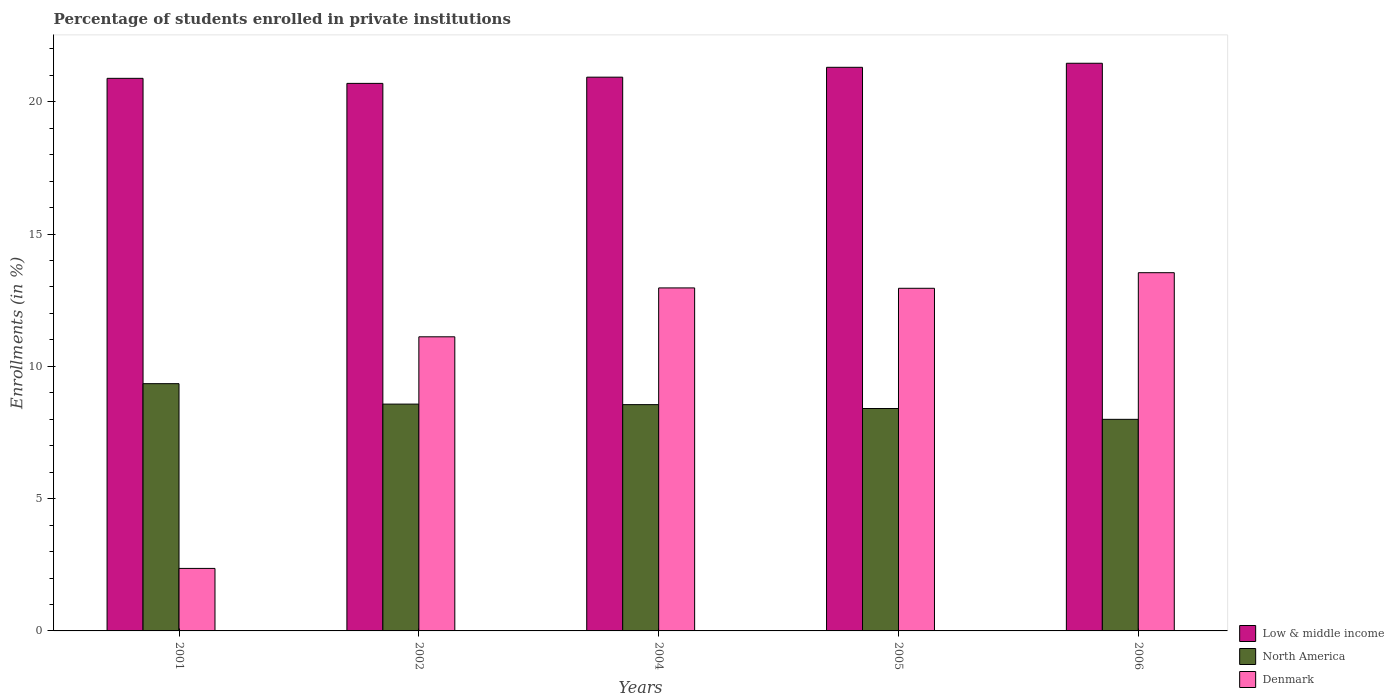How many different coloured bars are there?
Offer a terse response. 3. Are the number of bars per tick equal to the number of legend labels?
Provide a short and direct response. Yes. Are the number of bars on each tick of the X-axis equal?
Your response must be concise. Yes. How many bars are there on the 4th tick from the right?
Keep it short and to the point. 3. What is the percentage of trained teachers in Denmark in 2001?
Ensure brevity in your answer.  2.36. Across all years, what is the maximum percentage of trained teachers in North America?
Provide a short and direct response. 9.35. Across all years, what is the minimum percentage of trained teachers in Denmark?
Provide a succinct answer. 2.36. In which year was the percentage of trained teachers in Low & middle income minimum?
Make the answer very short. 2002. What is the total percentage of trained teachers in Low & middle income in the graph?
Your answer should be compact. 105.27. What is the difference between the percentage of trained teachers in Low & middle income in 2001 and that in 2006?
Give a very brief answer. -0.57. What is the difference between the percentage of trained teachers in North America in 2002 and the percentage of trained teachers in Denmark in 2004?
Provide a short and direct response. -4.39. What is the average percentage of trained teachers in Low & middle income per year?
Your answer should be compact. 21.05. In the year 2001, what is the difference between the percentage of trained teachers in Low & middle income and percentage of trained teachers in Denmark?
Offer a very short reply. 18.52. In how many years, is the percentage of trained teachers in Denmark greater than 4 %?
Ensure brevity in your answer.  4. What is the ratio of the percentage of trained teachers in North America in 2005 to that in 2006?
Ensure brevity in your answer.  1.05. What is the difference between the highest and the second highest percentage of trained teachers in North America?
Give a very brief answer. 0.77. What is the difference between the highest and the lowest percentage of trained teachers in Denmark?
Ensure brevity in your answer.  11.18. In how many years, is the percentage of trained teachers in Denmark greater than the average percentage of trained teachers in Denmark taken over all years?
Ensure brevity in your answer.  4. What does the 1st bar from the left in 2006 represents?
Make the answer very short. Low & middle income. What does the 2nd bar from the right in 2006 represents?
Offer a terse response. North America. How many bars are there?
Offer a very short reply. 15. What is the difference between two consecutive major ticks on the Y-axis?
Provide a short and direct response. 5. How are the legend labels stacked?
Provide a succinct answer. Vertical. What is the title of the graph?
Keep it short and to the point. Percentage of students enrolled in private institutions. Does "Kosovo" appear as one of the legend labels in the graph?
Offer a terse response. No. What is the label or title of the Y-axis?
Your response must be concise. Enrollments (in %). What is the Enrollments (in %) in Low & middle income in 2001?
Your response must be concise. 20.89. What is the Enrollments (in %) of North America in 2001?
Your answer should be compact. 9.35. What is the Enrollments (in %) of Denmark in 2001?
Provide a succinct answer. 2.36. What is the Enrollments (in %) of Low & middle income in 2002?
Your response must be concise. 20.7. What is the Enrollments (in %) of North America in 2002?
Provide a short and direct response. 8.57. What is the Enrollments (in %) in Denmark in 2002?
Offer a very short reply. 11.12. What is the Enrollments (in %) in Low & middle income in 2004?
Offer a very short reply. 20.93. What is the Enrollments (in %) in North America in 2004?
Make the answer very short. 8.55. What is the Enrollments (in %) of Denmark in 2004?
Provide a succinct answer. 12.96. What is the Enrollments (in %) in Low & middle income in 2005?
Your answer should be very brief. 21.3. What is the Enrollments (in %) in North America in 2005?
Your answer should be compact. 8.41. What is the Enrollments (in %) in Denmark in 2005?
Keep it short and to the point. 12.95. What is the Enrollments (in %) in Low & middle income in 2006?
Offer a terse response. 21.46. What is the Enrollments (in %) in North America in 2006?
Give a very brief answer. 8. What is the Enrollments (in %) of Denmark in 2006?
Provide a short and direct response. 13.54. Across all years, what is the maximum Enrollments (in %) in Low & middle income?
Your answer should be very brief. 21.46. Across all years, what is the maximum Enrollments (in %) in North America?
Offer a very short reply. 9.35. Across all years, what is the maximum Enrollments (in %) of Denmark?
Your response must be concise. 13.54. Across all years, what is the minimum Enrollments (in %) in Low & middle income?
Provide a short and direct response. 20.7. Across all years, what is the minimum Enrollments (in %) in North America?
Your answer should be very brief. 8. Across all years, what is the minimum Enrollments (in %) in Denmark?
Ensure brevity in your answer.  2.36. What is the total Enrollments (in %) of Low & middle income in the graph?
Offer a very short reply. 105.27. What is the total Enrollments (in %) of North America in the graph?
Your answer should be very brief. 42.88. What is the total Enrollments (in %) in Denmark in the graph?
Make the answer very short. 52.93. What is the difference between the Enrollments (in %) of Low & middle income in 2001 and that in 2002?
Give a very brief answer. 0.19. What is the difference between the Enrollments (in %) in North America in 2001 and that in 2002?
Give a very brief answer. 0.77. What is the difference between the Enrollments (in %) in Denmark in 2001 and that in 2002?
Offer a very short reply. -8.75. What is the difference between the Enrollments (in %) in Low & middle income in 2001 and that in 2004?
Provide a short and direct response. -0.04. What is the difference between the Enrollments (in %) of North America in 2001 and that in 2004?
Your response must be concise. 0.79. What is the difference between the Enrollments (in %) of Denmark in 2001 and that in 2004?
Keep it short and to the point. -10.6. What is the difference between the Enrollments (in %) of Low & middle income in 2001 and that in 2005?
Make the answer very short. -0.42. What is the difference between the Enrollments (in %) in North America in 2001 and that in 2005?
Offer a very short reply. 0.94. What is the difference between the Enrollments (in %) in Denmark in 2001 and that in 2005?
Ensure brevity in your answer.  -10.59. What is the difference between the Enrollments (in %) of Low & middle income in 2001 and that in 2006?
Ensure brevity in your answer.  -0.57. What is the difference between the Enrollments (in %) in North America in 2001 and that in 2006?
Make the answer very short. 1.35. What is the difference between the Enrollments (in %) of Denmark in 2001 and that in 2006?
Keep it short and to the point. -11.18. What is the difference between the Enrollments (in %) in Low & middle income in 2002 and that in 2004?
Your answer should be compact. -0.23. What is the difference between the Enrollments (in %) in North America in 2002 and that in 2004?
Your answer should be very brief. 0.02. What is the difference between the Enrollments (in %) in Denmark in 2002 and that in 2004?
Provide a short and direct response. -1.85. What is the difference between the Enrollments (in %) in Low & middle income in 2002 and that in 2005?
Provide a succinct answer. -0.61. What is the difference between the Enrollments (in %) in North America in 2002 and that in 2005?
Make the answer very short. 0.17. What is the difference between the Enrollments (in %) of Denmark in 2002 and that in 2005?
Provide a succinct answer. -1.83. What is the difference between the Enrollments (in %) in Low & middle income in 2002 and that in 2006?
Ensure brevity in your answer.  -0.76. What is the difference between the Enrollments (in %) in North America in 2002 and that in 2006?
Ensure brevity in your answer.  0.58. What is the difference between the Enrollments (in %) of Denmark in 2002 and that in 2006?
Keep it short and to the point. -2.42. What is the difference between the Enrollments (in %) in Low & middle income in 2004 and that in 2005?
Offer a very short reply. -0.37. What is the difference between the Enrollments (in %) of North America in 2004 and that in 2005?
Ensure brevity in your answer.  0.15. What is the difference between the Enrollments (in %) of Denmark in 2004 and that in 2005?
Your answer should be very brief. 0.01. What is the difference between the Enrollments (in %) in Low & middle income in 2004 and that in 2006?
Offer a very short reply. -0.53. What is the difference between the Enrollments (in %) of North America in 2004 and that in 2006?
Ensure brevity in your answer.  0.56. What is the difference between the Enrollments (in %) in Denmark in 2004 and that in 2006?
Keep it short and to the point. -0.58. What is the difference between the Enrollments (in %) of Low & middle income in 2005 and that in 2006?
Give a very brief answer. -0.15. What is the difference between the Enrollments (in %) of North America in 2005 and that in 2006?
Your answer should be compact. 0.41. What is the difference between the Enrollments (in %) in Denmark in 2005 and that in 2006?
Make the answer very short. -0.59. What is the difference between the Enrollments (in %) of Low & middle income in 2001 and the Enrollments (in %) of North America in 2002?
Provide a succinct answer. 12.31. What is the difference between the Enrollments (in %) of Low & middle income in 2001 and the Enrollments (in %) of Denmark in 2002?
Ensure brevity in your answer.  9.77. What is the difference between the Enrollments (in %) of North America in 2001 and the Enrollments (in %) of Denmark in 2002?
Offer a terse response. -1.77. What is the difference between the Enrollments (in %) of Low & middle income in 2001 and the Enrollments (in %) of North America in 2004?
Offer a terse response. 12.33. What is the difference between the Enrollments (in %) in Low & middle income in 2001 and the Enrollments (in %) in Denmark in 2004?
Give a very brief answer. 7.92. What is the difference between the Enrollments (in %) in North America in 2001 and the Enrollments (in %) in Denmark in 2004?
Offer a very short reply. -3.62. What is the difference between the Enrollments (in %) in Low & middle income in 2001 and the Enrollments (in %) in North America in 2005?
Provide a short and direct response. 12.48. What is the difference between the Enrollments (in %) in Low & middle income in 2001 and the Enrollments (in %) in Denmark in 2005?
Offer a very short reply. 7.94. What is the difference between the Enrollments (in %) in North America in 2001 and the Enrollments (in %) in Denmark in 2005?
Your answer should be compact. -3.6. What is the difference between the Enrollments (in %) of Low & middle income in 2001 and the Enrollments (in %) of North America in 2006?
Your answer should be very brief. 12.89. What is the difference between the Enrollments (in %) of Low & middle income in 2001 and the Enrollments (in %) of Denmark in 2006?
Provide a succinct answer. 7.35. What is the difference between the Enrollments (in %) of North America in 2001 and the Enrollments (in %) of Denmark in 2006?
Ensure brevity in your answer.  -4.19. What is the difference between the Enrollments (in %) in Low & middle income in 2002 and the Enrollments (in %) in North America in 2004?
Your answer should be compact. 12.14. What is the difference between the Enrollments (in %) in Low & middle income in 2002 and the Enrollments (in %) in Denmark in 2004?
Keep it short and to the point. 7.73. What is the difference between the Enrollments (in %) in North America in 2002 and the Enrollments (in %) in Denmark in 2004?
Offer a terse response. -4.39. What is the difference between the Enrollments (in %) in Low & middle income in 2002 and the Enrollments (in %) in North America in 2005?
Provide a short and direct response. 12.29. What is the difference between the Enrollments (in %) in Low & middle income in 2002 and the Enrollments (in %) in Denmark in 2005?
Give a very brief answer. 7.75. What is the difference between the Enrollments (in %) in North America in 2002 and the Enrollments (in %) in Denmark in 2005?
Keep it short and to the point. -4.38. What is the difference between the Enrollments (in %) in Low & middle income in 2002 and the Enrollments (in %) in North America in 2006?
Your response must be concise. 12.7. What is the difference between the Enrollments (in %) in Low & middle income in 2002 and the Enrollments (in %) in Denmark in 2006?
Make the answer very short. 7.16. What is the difference between the Enrollments (in %) of North America in 2002 and the Enrollments (in %) of Denmark in 2006?
Provide a succinct answer. -4.97. What is the difference between the Enrollments (in %) in Low & middle income in 2004 and the Enrollments (in %) in North America in 2005?
Your answer should be compact. 12.52. What is the difference between the Enrollments (in %) of Low & middle income in 2004 and the Enrollments (in %) of Denmark in 2005?
Your answer should be very brief. 7.98. What is the difference between the Enrollments (in %) of North America in 2004 and the Enrollments (in %) of Denmark in 2005?
Your answer should be very brief. -4.4. What is the difference between the Enrollments (in %) in Low & middle income in 2004 and the Enrollments (in %) in North America in 2006?
Ensure brevity in your answer.  12.93. What is the difference between the Enrollments (in %) in Low & middle income in 2004 and the Enrollments (in %) in Denmark in 2006?
Provide a succinct answer. 7.39. What is the difference between the Enrollments (in %) in North America in 2004 and the Enrollments (in %) in Denmark in 2006?
Make the answer very short. -4.99. What is the difference between the Enrollments (in %) of Low & middle income in 2005 and the Enrollments (in %) of North America in 2006?
Your answer should be compact. 13.31. What is the difference between the Enrollments (in %) in Low & middle income in 2005 and the Enrollments (in %) in Denmark in 2006?
Offer a terse response. 7.76. What is the difference between the Enrollments (in %) in North America in 2005 and the Enrollments (in %) in Denmark in 2006?
Give a very brief answer. -5.13. What is the average Enrollments (in %) in Low & middle income per year?
Your response must be concise. 21.05. What is the average Enrollments (in %) in North America per year?
Offer a terse response. 8.58. What is the average Enrollments (in %) of Denmark per year?
Offer a terse response. 10.59. In the year 2001, what is the difference between the Enrollments (in %) of Low & middle income and Enrollments (in %) of North America?
Your response must be concise. 11.54. In the year 2001, what is the difference between the Enrollments (in %) of Low & middle income and Enrollments (in %) of Denmark?
Provide a short and direct response. 18.52. In the year 2001, what is the difference between the Enrollments (in %) in North America and Enrollments (in %) in Denmark?
Offer a terse response. 6.98. In the year 2002, what is the difference between the Enrollments (in %) of Low & middle income and Enrollments (in %) of North America?
Your response must be concise. 12.12. In the year 2002, what is the difference between the Enrollments (in %) of Low & middle income and Enrollments (in %) of Denmark?
Make the answer very short. 9.58. In the year 2002, what is the difference between the Enrollments (in %) of North America and Enrollments (in %) of Denmark?
Provide a succinct answer. -2.54. In the year 2004, what is the difference between the Enrollments (in %) of Low & middle income and Enrollments (in %) of North America?
Offer a terse response. 12.38. In the year 2004, what is the difference between the Enrollments (in %) of Low & middle income and Enrollments (in %) of Denmark?
Provide a succinct answer. 7.97. In the year 2004, what is the difference between the Enrollments (in %) in North America and Enrollments (in %) in Denmark?
Your answer should be compact. -4.41. In the year 2005, what is the difference between the Enrollments (in %) of Low & middle income and Enrollments (in %) of North America?
Give a very brief answer. 12.9. In the year 2005, what is the difference between the Enrollments (in %) of Low & middle income and Enrollments (in %) of Denmark?
Your answer should be very brief. 8.35. In the year 2005, what is the difference between the Enrollments (in %) in North America and Enrollments (in %) in Denmark?
Offer a very short reply. -4.54. In the year 2006, what is the difference between the Enrollments (in %) of Low & middle income and Enrollments (in %) of North America?
Provide a short and direct response. 13.46. In the year 2006, what is the difference between the Enrollments (in %) in Low & middle income and Enrollments (in %) in Denmark?
Provide a short and direct response. 7.92. In the year 2006, what is the difference between the Enrollments (in %) in North America and Enrollments (in %) in Denmark?
Offer a very short reply. -5.54. What is the ratio of the Enrollments (in %) of Low & middle income in 2001 to that in 2002?
Offer a terse response. 1.01. What is the ratio of the Enrollments (in %) in North America in 2001 to that in 2002?
Ensure brevity in your answer.  1.09. What is the ratio of the Enrollments (in %) of Denmark in 2001 to that in 2002?
Provide a succinct answer. 0.21. What is the ratio of the Enrollments (in %) of North America in 2001 to that in 2004?
Give a very brief answer. 1.09. What is the ratio of the Enrollments (in %) in Denmark in 2001 to that in 2004?
Ensure brevity in your answer.  0.18. What is the ratio of the Enrollments (in %) of Low & middle income in 2001 to that in 2005?
Your response must be concise. 0.98. What is the ratio of the Enrollments (in %) of North America in 2001 to that in 2005?
Offer a very short reply. 1.11. What is the ratio of the Enrollments (in %) in Denmark in 2001 to that in 2005?
Offer a very short reply. 0.18. What is the ratio of the Enrollments (in %) in Low & middle income in 2001 to that in 2006?
Provide a short and direct response. 0.97. What is the ratio of the Enrollments (in %) of North America in 2001 to that in 2006?
Make the answer very short. 1.17. What is the ratio of the Enrollments (in %) in Denmark in 2001 to that in 2006?
Give a very brief answer. 0.17. What is the ratio of the Enrollments (in %) in Low & middle income in 2002 to that in 2004?
Give a very brief answer. 0.99. What is the ratio of the Enrollments (in %) in North America in 2002 to that in 2004?
Your answer should be very brief. 1. What is the ratio of the Enrollments (in %) in Denmark in 2002 to that in 2004?
Offer a terse response. 0.86. What is the ratio of the Enrollments (in %) of Low & middle income in 2002 to that in 2005?
Offer a very short reply. 0.97. What is the ratio of the Enrollments (in %) of North America in 2002 to that in 2005?
Keep it short and to the point. 1.02. What is the ratio of the Enrollments (in %) in Denmark in 2002 to that in 2005?
Your response must be concise. 0.86. What is the ratio of the Enrollments (in %) of Low & middle income in 2002 to that in 2006?
Your answer should be very brief. 0.96. What is the ratio of the Enrollments (in %) of North America in 2002 to that in 2006?
Offer a terse response. 1.07. What is the ratio of the Enrollments (in %) in Denmark in 2002 to that in 2006?
Give a very brief answer. 0.82. What is the ratio of the Enrollments (in %) of Low & middle income in 2004 to that in 2005?
Ensure brevity in your answer.  0.98. What is the ratio of the Enrollments (in %) of North America in 2004 to that in 2005?
Provide a succinct answer. 1.02. What is the ratio of the Enrollments (in %) of Denmark in 2004 to that in 2005?
Keep it short and to the point. 1. What is the ratio of the Enrollments (in %) of Low & middle income in 2004 to that in 2006?
Offer a terse response. 0.98. What is the ratio of the Enrollments (in %) in North America in 2004 to that in 2006?
Your answer should be compact. 1.07. What is the ratio of the Enrollments (in %) of Denmark in 2004 to that in 2006?
Your answer should be very brief. 0.96. What is the ratio of the Enrollments (in %) in Low & middle income in 2005 to that in 2006?
Ensure brevity in your answer.  0.99. What is the ratio of the Enrollments (in %) of North America in 2005 to that in 2006?
Your answer should be compact. 1.05. What is the ratio of the Enrollments (in %) of Denmark in 2005 to that in 2006?
Ensure brevity in your answer.  0.96. What is the difference between the highest and the second highest Enrollments (in %) in Low & middle income?
Give a very brief answer. 0.15. What is the difference between the highest and the second highest Enrollments (in %) in North America?
Offer a terse response. 0.77. What is the difference between the highest and the second highest Enrollments (in %) of Denmark?
Ensure brevity in your answer.  0.58. What is the difference between the highest and the lowest Enrollments (in %) in Low & middle income?
Your answer should be very brief. 0.76. What is the difference between the highest and the lowest Enrollments (in %) of North America?
Keep it short and to the point. 1.35. What is the difference between the highest and the lowest Enrollments (in %) in Denmark?
Your answer should be compact. 11.18. 